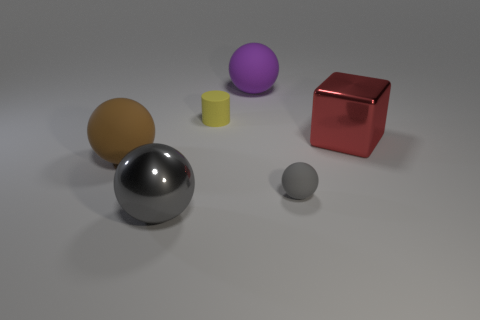There is a object that is the same color as the metal sphere; what shape is it?
Your answer should be very brief. Sphere. Is the number of cyan rubber balls less than the number of big matte spheres?
Keep it short and to the point. Yes. What number of big things are either cylinders or purple matte spheres?
Make the answer very short. 1. How many large objects are both to the right of the brown sphere and behind the large gray shiny object?
Your answer should be compact. 2. Are there more big metal balls than matte objects?
Ensure brevity in your answer.  No. What number of other things are there of the same shape as the big red object?
Provide a short and direct response. 0. Is the tiny ball the same color as the big metal block?
Make the answer very short. No. What is the material of the large sphere that is in front of the small yellow matte thing and to the right of the big brown matte ball?
Give a very brief answer. Metal. How big is the brown ball?
Your response must be concise. Large. There is a large matte object in front of the big purple sphere that is to the right of the small cylinder; how many yellow matte things are behind it?
Offer a very short reply. 1. 